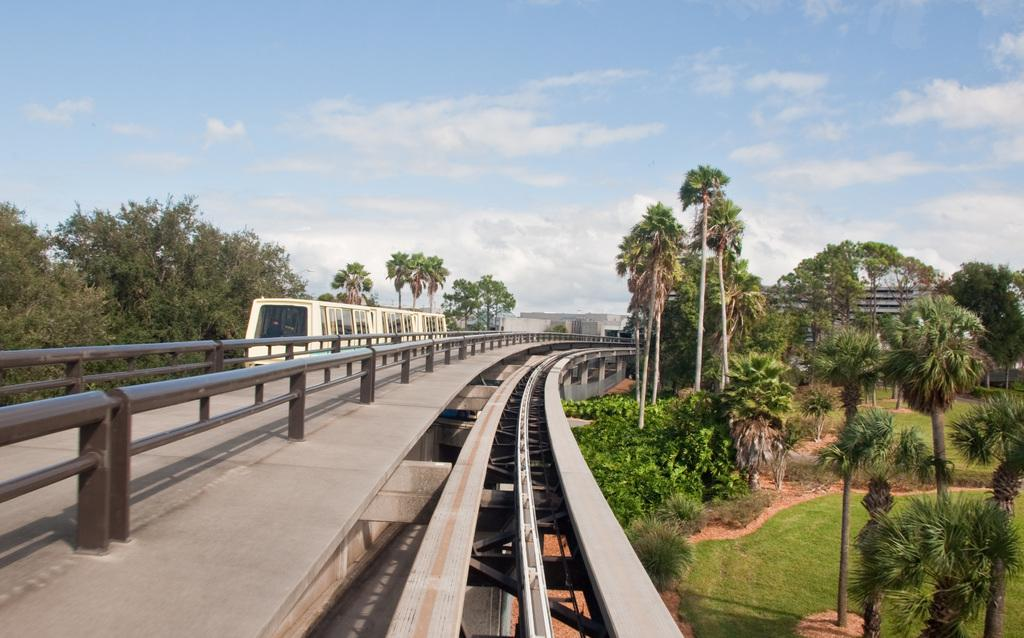What is the weather like in the image? The sky is cloudy in the image. What is the main subject of the image? There is a train in the image. What type of vegetation can be seen in the image? There are trees, plants, and grass in the image. Can you tell me how many cushions are on the train in the image? There are no cushions visible on the train in the image. What wish does the person in the image have? There is no person present in the image, so it is impossible to determine their wishes. 